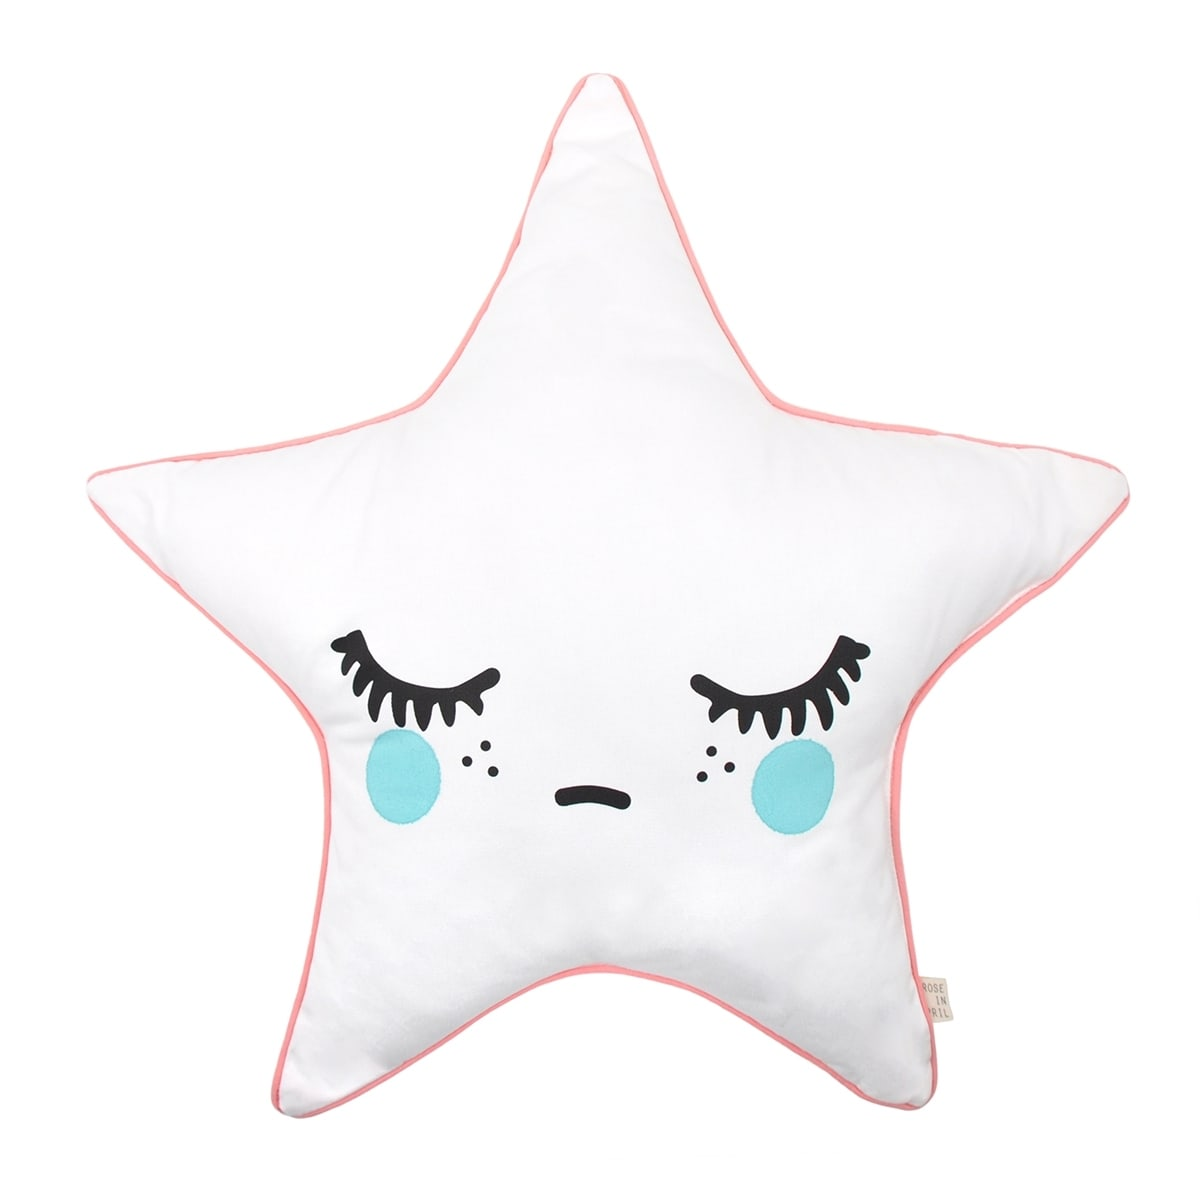Let's pretend this pillow is a star from a different galaxy. Describe a detailed adventure it might experience. In a distant galaxy far beyond our own, the star-shaped pillow, named Lumina, was not just any star. Lumina had the unique ability to bring dreams to life. One night, she was plucked from a celestial nursery by a swift comet and whisked away on an interstellar journey. She visited planets made entirely of crystal where she refracted light into dazzling rainbows, played tag with playful meteor showers, and visited a galactic library guarded by wise old star sages who shared ancient cosmic secrets. Lumina even helped a young stardust sprite named Nova find her way back home. Throughout her adventure, Lumina collected magical dream dust that she would later sprinkle over children on Earth, ensuring their dreams were filled with wonder and magic. By the end of her journey, she returned to her rightful place in the galaxy, glowing brighter than before, filled with the wisdom and memories of her grand adventure. 